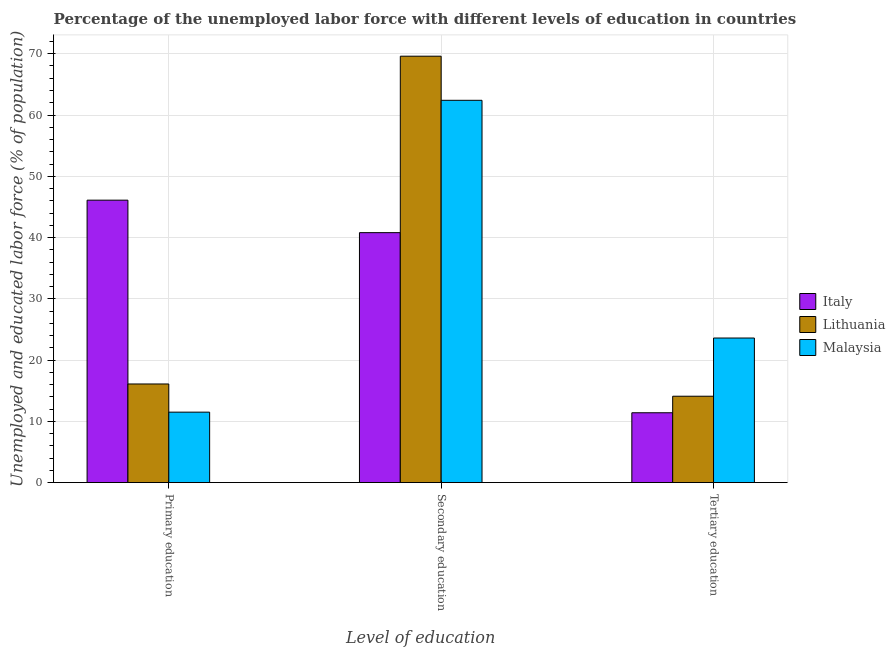How many different coloured bars are there?
Make the answer very short. 3. Are the number of bars per tick equal to the number of legend labels?
Your answer should be very brief. Yes. Are the number of bars on each tick of the X-axis equal?
Provide a short and direct response. Yes. How many bars are there on the 3rd tick from the left?
Your answer should be very brief. 3. How many bars are there on the 2nd tick from the right?
Offer a terse response. 3. What is the label of the 3rd group of bars from the left?
Keep it short and to the point. Tertiary education. What is the percentage of labor force who received secondary education in Malaysia?
Offer a very short reply. 62.4. Across all countries, what is the maximum percentage of labor force who received secondary education?
Your answer should be very brief. 69.6. Across all countries, what is the minimum percentage of labor force who received tertiary education?
Keep it short and to the point. 11.4. In which country was the percentage of labor force who received tertiary education maximum?
Make the answer very short. Malaysia. What is the total percentage of labor force who received primary education in the graph?
Your response must be concise. 73.7. What is the difference between the percentage of labor force who received tertiary education in Malaysia and that in Italy?
Provide a short and direct response. 12.2. What is the difference between the percentage of labor force who received tertiary education in Malaysia and the percentage of labor force who received secondary education in Italy?
Provide a succinct answer. -17.2. What is the average percentage of labor force who received primary education per country?
Provide a short and direct response. 24.57. What is the difference between the percentage of labor force who received secondary education and percentage of labor force who received tertiary education in Malaysia?
Ensure brevity in your answer.  38.8. What is the ratio of the percentage of labor force who received secondary education in Lithuania to that in Malaysia?
Ensure brevity in your answer.  1.12. Is the difference between the percentage of labor force who received secondary education in Lithuania and Italy greater than the difference between the percentage of labor force who received tertiary education in Lithuania and Italy?
Your answer should be compact. Yes. What is the difference between the highest and the second highest percentage of labor force who received tertiary education?
Make the answer very short. 9.5. What is the difference between the highest and the lowest percentage of labor force who received primary education?
Your response must be concise. 34.6. In how many countries, is the percentage of labor force who received secondary education greater than the average percentage of labor force who received secondary education taken over all countries?
Give a very brief answer. 2. What does the 1st bar from the left in Tertiary education represents?
Offer a terse response. Italy. What does the 2nd bar from the right in Primary education represents?
Your answer should be compact. Lithuania. Is it the case that in every country, the sum of the percentage of labor force who received primary education and percentage of labor force who received secondary education is greater than the percentage of labor force who received tertiary education?
Provide a short and direct response. Yes. How many bars are there?
Make the answer very short. 9. Are the values on the major ticks of Y-axis written in scientific E-notation?
Provide a short and direct response. No. Does the graph contain any zero values?
Your answer should be compact. No. Does the graph contain grids?
Make the answer very short. Yes. How many legend labels are there?
Your answer should be compact. 3. What is the title of the graph?
Ensure brevity in your answer.  Percentage of the unemployed labor force with different levels of education in countries. What is the label or title of the X-axis?
Offer a terse response. Level of education. What is the label or title of the Y-axis?
Keep it short and to the point. Unemployed and educated labor force (% of population). What is the Unemployed and educated labor force (% of population) of Italy in Primary education?
Offer a very short reply. 46.1. What is the Unemployed and educated labor force (% of population) of Lithuania in Primary education?
Make the answer very short. 16.1. What is the Unemployed and educated labor force (% of population) of Italy in Secondary education?
Your answer should be very brief. 40.8. What is the Unemployed and educated labor force (% of population) of Lithuania in Secondary education?
Your response must be concise. 69.6. What is the Unemployed and educated labor force (% of population) of Malaysia in Secondary education?
Provide a succinct answer. 62.4. What is the Unemployed and educated labor force (% of population) in Italy in Tertiary education?
Your answer should be very brief. 11.4. What is the Unemployed and educated labor force (% of population) of Lithuania in Tertiary education?
Offer a very short reply. 14.1. What is the Unemployed and educated labor force (% of population) of Malaysia in Tertiary education?
Keep it short and to the point. 23.6. Across all Level of education, what is the maximum Unemployed and educated labor force (% of population) in Italy?
Offer a very short reply. 46.1. Across all Level of education, what is the maximum Unemployed and educated labor force (% of population) in Lithuania?
Offer a terse response. 69.6. Across all Level of education, what is the maximum Unemployed and educated labor force (% of population) of Malaysia?
Provide a short and direct response. 62.4. Across all Level of education, what is the minimum Unemployed and educated labor force (% of population) of Italy?
Your response must be concise. 11.4. Across all Level of education, what is the minimum Unemployed and educated labor force (% of population) of Lithuania?
Provide a short and direct response. 14.1. Across all Level of education, what is the minimum Unemployed and educated labor force (% of population) of Malaysia?
Provide a succinct answer. 11.5. What is the total Unemployed and educated labor force (% of population) of Italy in the graph?
Offer a terse response. 98.3. What is the total Unemployed and educated labor force (% of population) of Lithuania in the graph?
Give a very brief answer. 99.8. What is the total Unemployed and educated labor force (% of population) of Malaysia in the graph?
Ensure brevity in your answer.  97.5. What is the difference between the Unemployed and educated labor force (% of population) of Italy in Primary education and that in Secondary education?
Provide a succinct answer. 5.3. What is the difference between the Unemployed and educated labor force (% of population) of Lithuania in Primary education and that in Secondary education?
Provide a short and direct response. -53.5. What is the difference between the Unemployed and educated labor force (% of population) of Malaysia in Primary education and that in Secondary education?
Give a very brief answer. -50.9. What is the difference between the Unemployed and educated labor force (% of population) in Italy in Primary education and that in Tertiary education?
Give a very brief answer. 34.7. What is the difference between the Unemployed and educated labor force (% of population) of Lithuania in Primary education and that in Tertiary education?
Give a very brief answer. 2. What is the difference between the Unemployed and educated labor force (% of population) of Italy in Secondary education and that in Tertiary education?
Provide a short and direct response. 29.4. What is the difference between the Unemployed and educated labor force (% of population) of Lithuania in Secondary education and that in Tertiary education?
Offer a terse response. 55.5. What is the difference between the Unemployed and educated labor force (% of population) of Malaysia in Secondary education and that in Tertiary education?
Offer a terse response. 38.8. What is the difference between the Unemployed and educated labor force (% of population) of Italy in Primary education and the Unemployed and educated labor force (% of population) of Lithuania in Secondary education?
Your response must be concise. -23.5. What is the difference between the Unemployed and educated labor force (% of population) of Italy in Primary education and the Unemployed and educated labor force (% of population) of Malaysia in Secondary education?
Your answer should be compact. -16.3. What is the difference between the Unemployed and educated labor force (% of population) in Lithuania in Primary education and the Unemployed and educated labor force (% of population) in Malaysia in Secondary education?
Make the answer very short. -46.3. What is the difference between the Unemployed and educated labor force (% of population) in Italy in Primary education and the Unemployed and educated labor force (% of population) in Lithuania in Tertiary education?
Offer a terse response. 32. What is the difference between the Unemployed and educated labor force (% of population) in Italy in Primary education and the Unemployed and educated labor force (% of population) in Malaysia in Tertiary education?
Offer a terse response. 22.5. What is the difference between the Unemployed and educated labor force (% of population) in Lithuania in Primary education and the Unemployed and educated labor force (% of population) in Malaysia in Tertiary education?
Your answer should be very brief. -7.5. What is the difference between the Unemployed and educated labor force (% of population) of Italy in Secondary education and the Unemployed and educated labor force (% of population) of Lithuania in Tertiary education?
Provide a succinct answer. 26.7. What is the average Unemployed and educated labor force (% of population) of Italy per Level of education?
Your answer should be compact. 32.77. What is the average Unemployed and educated labor force (% of population) in Lithuania per Level of education?
Offer a terse response. 33.27. What is the average Unemployed and educated labor force (% of population) of Malaysia per Level of education?
Give a very brief answer. 32.5. What is the difference between the Unemployed and educated labor force (% of population) of Italy and Unemployed and educated labor force (% of population) of Lithuania in Primary education?
Offer a very short reply. 30. What is the difference between the Unemployed and educated labor force (% of population) of Italy and Unemployed and educated labor force (% of population) of Malaysia in Primary education?
Your response must be concise. 34.6. What is the difference between the Unemployed and educated labor force (% of population) in Italy and Unemployed and educated labor force (% of population) in Lithuania in Secondary education?
Offer a very short reply. -28.8. What is the difference between the Unemployed and educated labor force (% of population) of Italy and Unemployed and educated labor force (% of population) of Malaysia in Secondary education?
Give a very brief answer. -21.6. What is the difference between the Unemployed and educated labor force (% of population) of Lithuania and Unemployed and educated labor force (% of population) of Malaysia in Tertiary education?
Your answer should be very brief. -9.5. What is the ratio of the Unemployed and educated labor force (% of population) of Italy in Primary education to that in Secondary education?
Keep it short and to the point. 1.13. What is the ratio of the Unemployed and educated labor force (% of population) of Lithuania in Primary education to that in Secondary education?
Your answer should be compact. 0.23. What is the ratio of the Unemployed and educated labor force (% of population) of Malaysia in Primary education to that in Secondary education?
Keep it short and to the point. 0.18. What is the ratio of the Unemployed and educated labor force (% of population) of Italy in Primary education to that in Tertiary education?
Make the answer very short. 4.04. What is the ratio of the Unemployed and educated labor force (% of population) in Lithuania in Primary education to that in Tertiary education?
Offer a terse response. 1.14. What is the ratio of the Unemployed and educated labor force (% of population) of Malaysia in Primary education to that in Tertiary education?
Keep it short and to the point. 0.49. What is the ratio of the Unemployed and educated labor force (% of population) of Italy in Secondary education to that in Tertiary education?
Keep it short and to the point. 3.58. What is the ratio of the Unemployed and educated labor force (% of population) in Lithuania in Secondary education to that in Tertiary education?
Make the answer very short. 4.94. What is the ratio of the Unemployed and educated labor force (% of population) in Malaysia in Secondary education to that in Tertiary education?
Offer a very short reply. 2.64. What is the difference between the highest and the second highest Unemployed and educated labor force (% of population) of Lithuania?
Keep it short and to the point. 53.5. What is the difference between the highest and the second highest Unemployed and educated labor force (% of population) in Malaysia?
Offer a very short reply. 38.8. What is the difference between the highest and the lowest Unemployed and educated labor force (% of population) in Italy?
Your answer should be very brief. 34.7. What is the difference between the highest and the lowest Unemployed and educated labor force (% of population) in Lithuania?
Provide a succinct answer. 55.5. What is the difference between the highest and the lowest Unemployed and educated labor force (% of population) in Malaysia?
Your answer should be very brief. 50.9. 